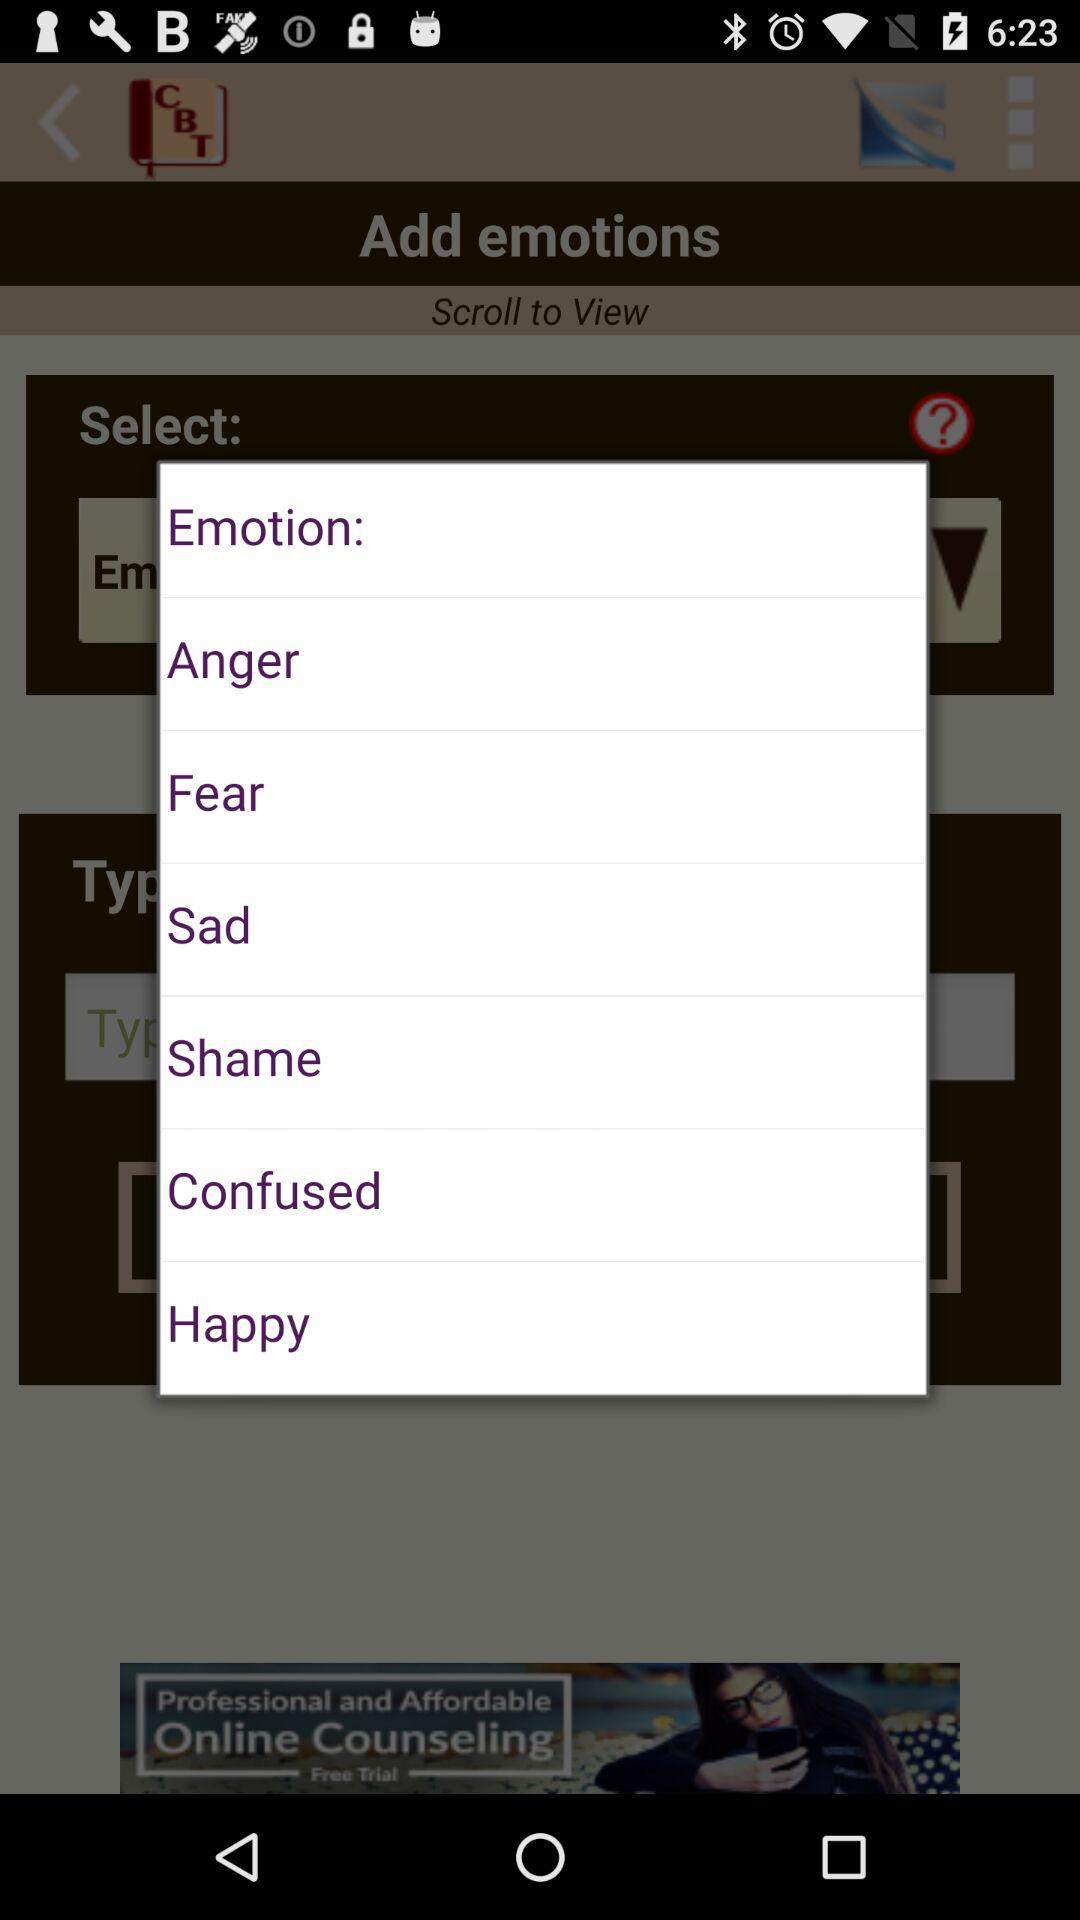How many emotion options are displayed?
Answer the question using a single word or phrase. 7 